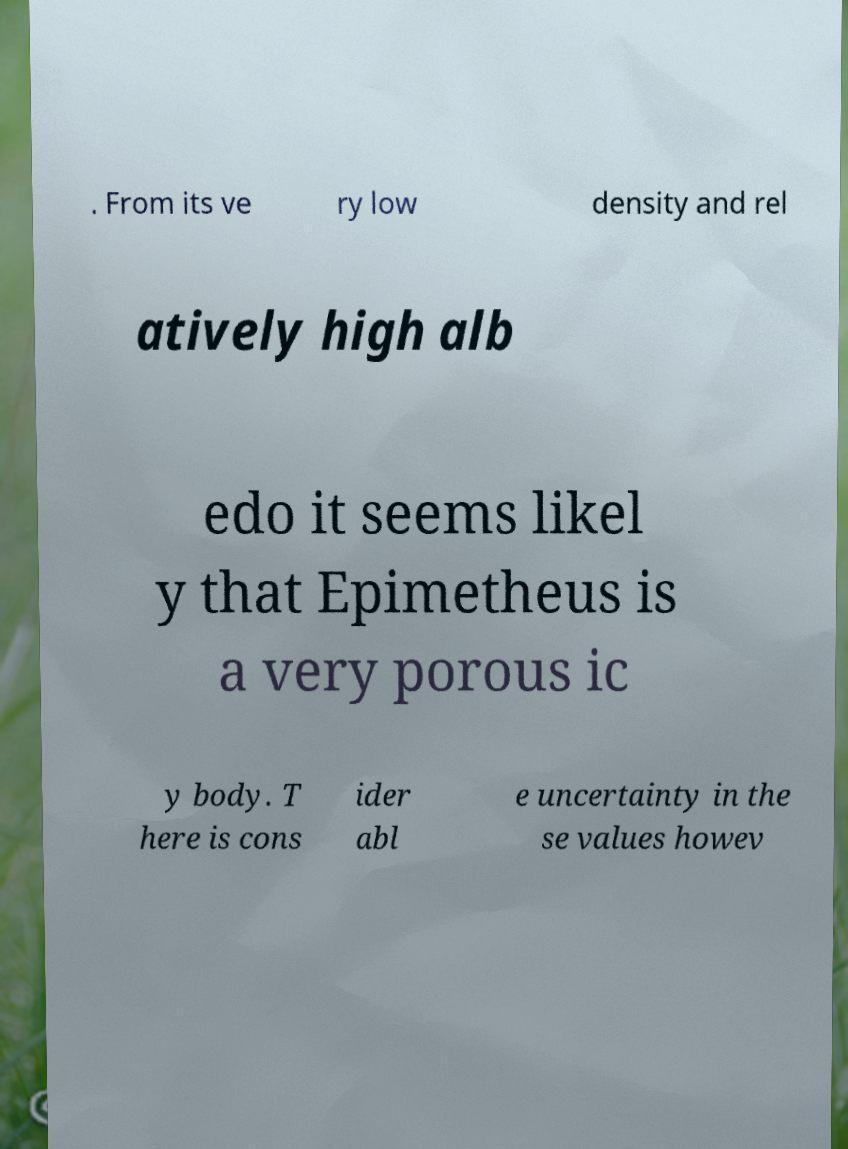Please identify and transcribe the text found in this image. . From its ve ry low density and rel atively high alb edo it seems likel y that Epimetheus is a very porous ic y body. T here is cons ider abl e uncertainty in the se values howev 